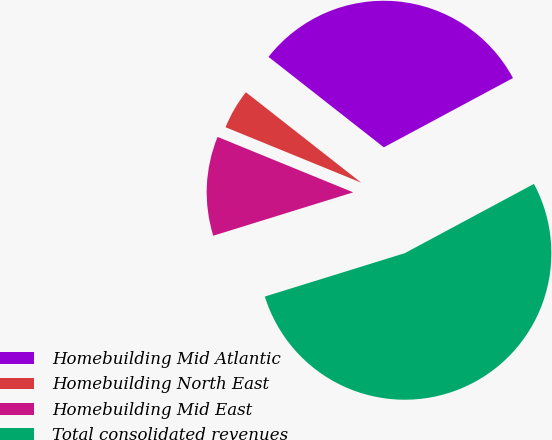Convert chart to OTSL. <chart><loc_0><loc_0><loc_500><loc_500><pie_chart><fcel>Homebuilding Mid Atlantic<fcel>Homebuilding North East<fcel>Homebuilding Mid East<fcel>Total consolidated revenues<nl><fcel>31.58%<fcel>4.41%<fcel>10.96%<fcel>53.05%<nl></chart> 